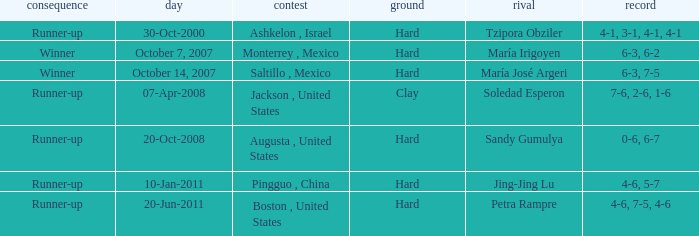What was the outcome when Jing-Jing Lu was the opponent? Runner-up. 